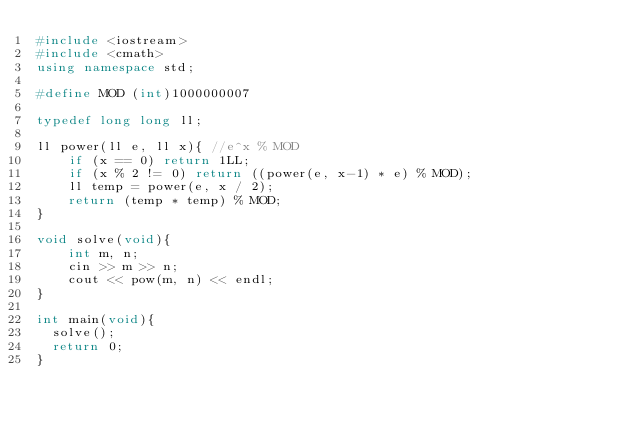<code> <loc_0><loc_0><loc_500><loc_500><_C++_>#include <iostream>
#include <cmath>
using namespace std;

#define MOD (int)1000000007

typedef long long ll;

ll power(ll e, ll x){ //e^x % MOD
    if (x == 0) return 1LL;
    if (x % 2 != 0) return ((power(e, x-1) * e) % MOD);
    ll temp = power(e, x / 2);
    return (temp * temp) % MOD;
}

void solve(void){
    int m, n;
    cin >> m >> n;
    cout << pow(m, n) << endl;
}

int main(void){
  solve();
  return 0;
}

</code> 